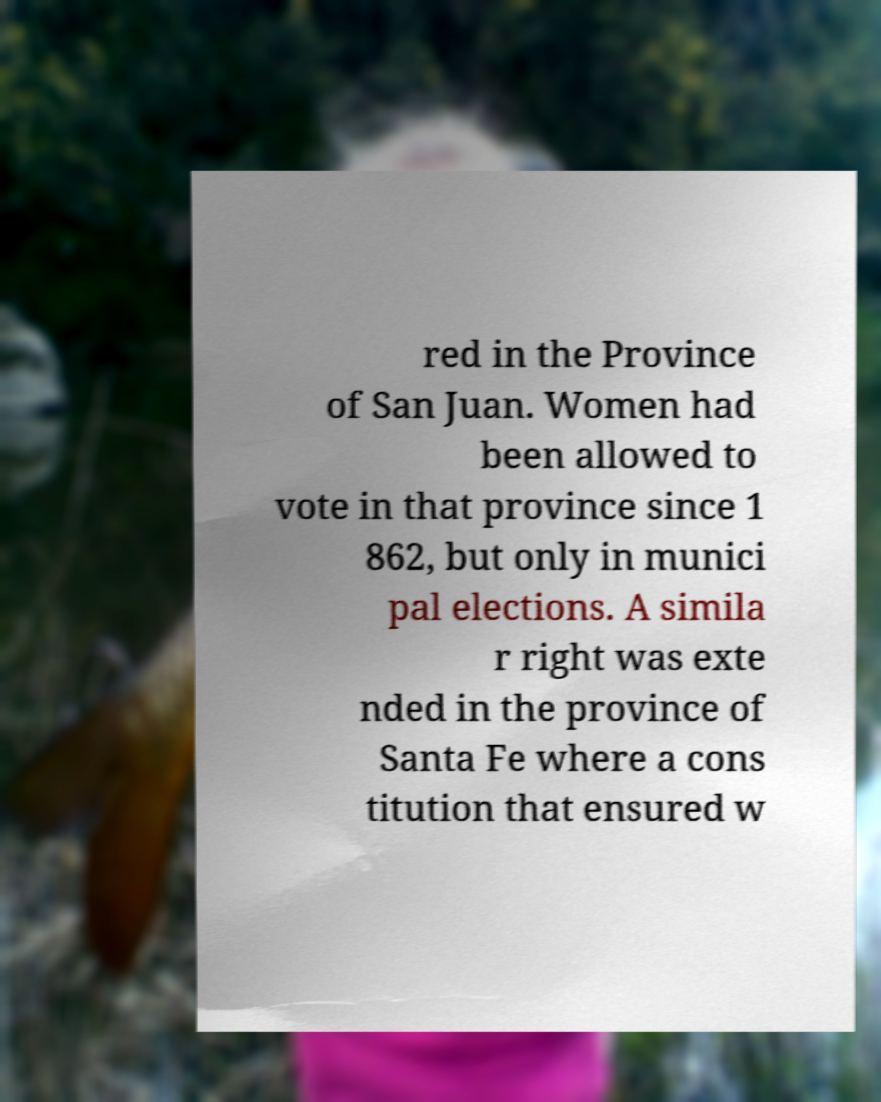For documentation purposes, I need the text within this image transcribed. Could you provide that? red in the Province of San Juan. Women had been allowed to vote in that province since 1 862, but only in munici pal elections. A simila r right was exte nded in the province of Santa Fe where a cons titution that ensured w 